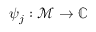Convert formula to latex. <formula><loc_0><loc_0><loc_500><loc_500>\psi _ { j } \colon \mathcal { M } \rightarrow \mathbb { C }</formula> 